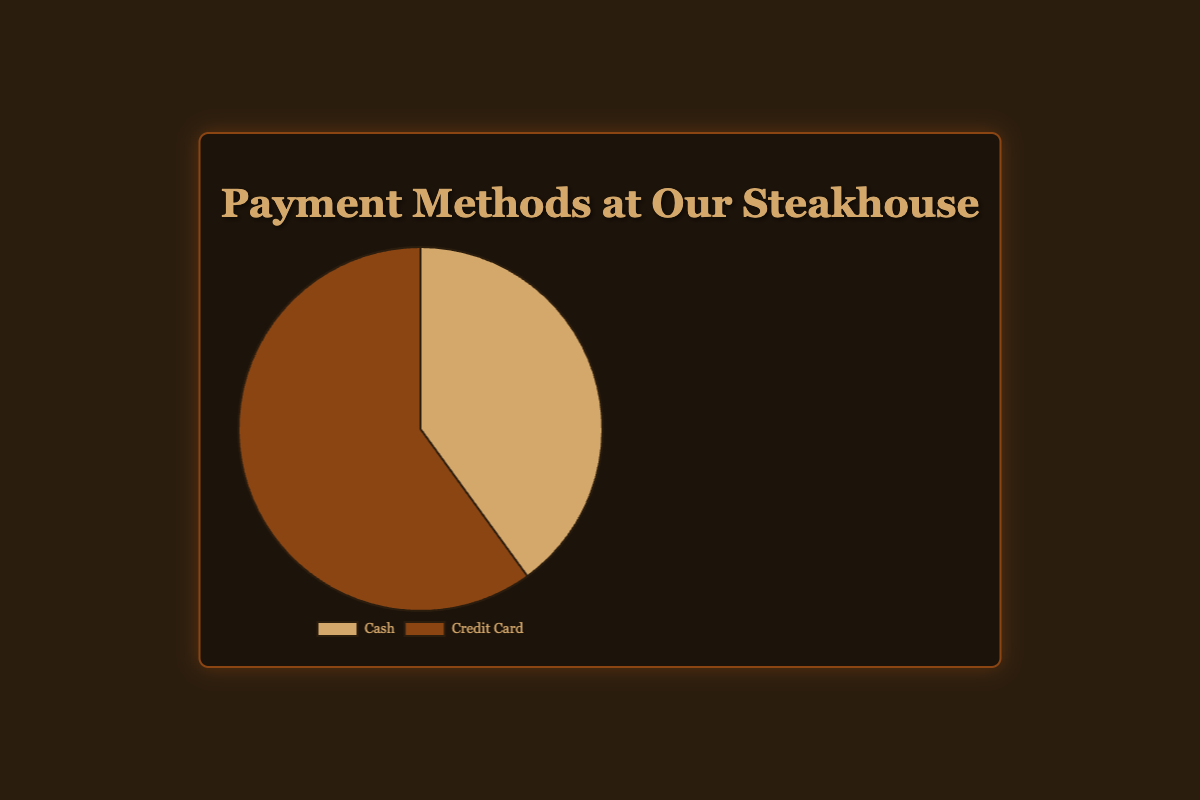What percentage of our customers use credit cards? The data shows that the proportion of customers using credit cards is 60%.
Answer: 60% Which payment method is more popular among our customers, cash or credit card? The figure shows that 60% of customers use credit cards and 40% use cash. Since 60% is greater than 40%, credit card is more popular.
Answer: Credit card What percentage of transactions are made in cash? According to the data provided, 40% of transactions are made in cash.
Answer: 40% By how many percentage points does the use of credit cards exceed that of cash? The difference between the percentage of credit card transactions (60%) and cash transactions (40%) is calculated as 60% - 40% = 20%.
Answer: 20% What fraction of payments is made via cash compared to credit card? The figure shows 40% of payments are made by cash and 60% by credit card. The fraction is 40:60, which simplifies to 2:3.
Answer: 2:3 What is the total percentage of transactions accounted for by both methods combined? The sum of the percentages for cash (40%) and credit card (60%) is calculated as 40% + 60% = 100%.
Answer: 100% Which color represents cash transactions in the pie chart? The pie chart uses a specific color to denote cash transactions. The color corresponding to 40% (cash) is a light gold shade.
Answer: Light gold What is the percentage of non-cash transactions? Since cash transactions account for 40%, non-cash transactions like credit cards account for the remaining percentage, 100% - 40% = 60%.
Answer: 60% What is the difference between the highest and lowest percentages shown in the chart? The highest percentage (credit card) is 60%, and the lowest (cash) is 40%. The difference is calculated as 60% - 40% = 20%.
Answer: 20% 